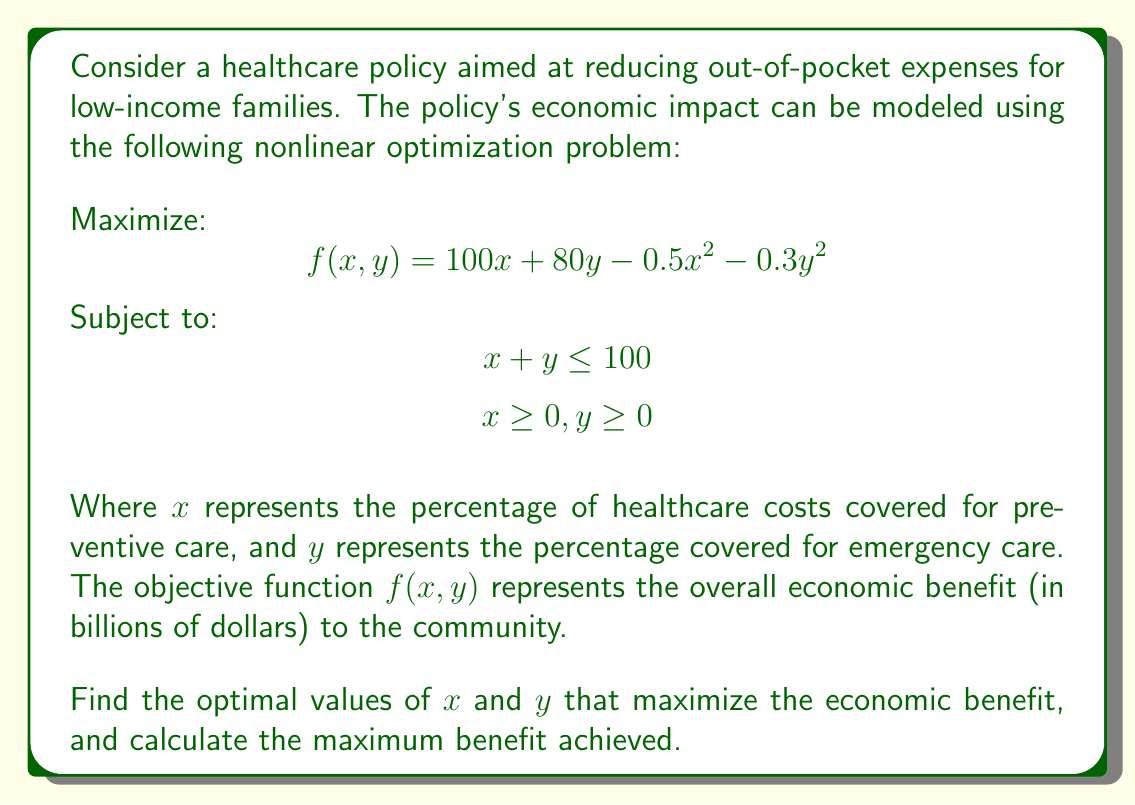Could you help me with this problem? To solve this nonlinear optimization problem, we'll use the method of Lagrange multipliers:

1) Form the Lagrangian function:
   $$ L(x, y, \lambda) = 100x + 80y - 0.5x^2 - 0.3y^2 - \lambda(x + y - 100) $$

2) Take partial derivatives and set them to zero:
   $$ \frac{\partial L}{\partial x} = 100 - x - \lambda = 0 $$
   $$ \frac{\partial L}{\partial y} = 80 - 0.6y - \lambda = 0 $$
   $$ \frac{\partial L}{\partial \lambda} = 100 - x - y = 0 $$

3) From the first equation: $x = 100 - \lambda$
   From the second equation: $y = \frac{80 - \lambda}{0.6} = \frac{400 - 5\lambda}{3}$

4) Substitute these into the third equation:
   $$ 100 - (100 - \lambda) - \frac{400 - 5\lambda}{3} = 0 $$

5) Solve for $\lambda$:
   $$ \lambda - \frac{400 - 5\lambda}{3} = 0 $$
   $$ 3\lambda - 400 + 5\lambda = 0 $$
   $$ 8\lambda = 400 $$
   $$ \lambda = 50 $$

6) Substitute back to find $x$ and $y$:
   $$ x = 100 - 50 = 50 $$
   $$ y = \frac{400 - 5(50)}{3} = \frac{150}{3} = 50 $$

7) Calculate the maximum benefit:
   $$ f(50, 50) = 100(50) + 80(50) - 0.5(50)^2 - 0.3(50)^2 $$
   $$ = 5000 + 4000 - 1250 - 750 = 7000 $$

Therefore, the optimal solution is to cover 50% of both preventive and emergency care costs, resulting in a maximum economic benefit of $7 billion.
Answer: $x = 50, y = 50, f(50, 50) = 7000$ 